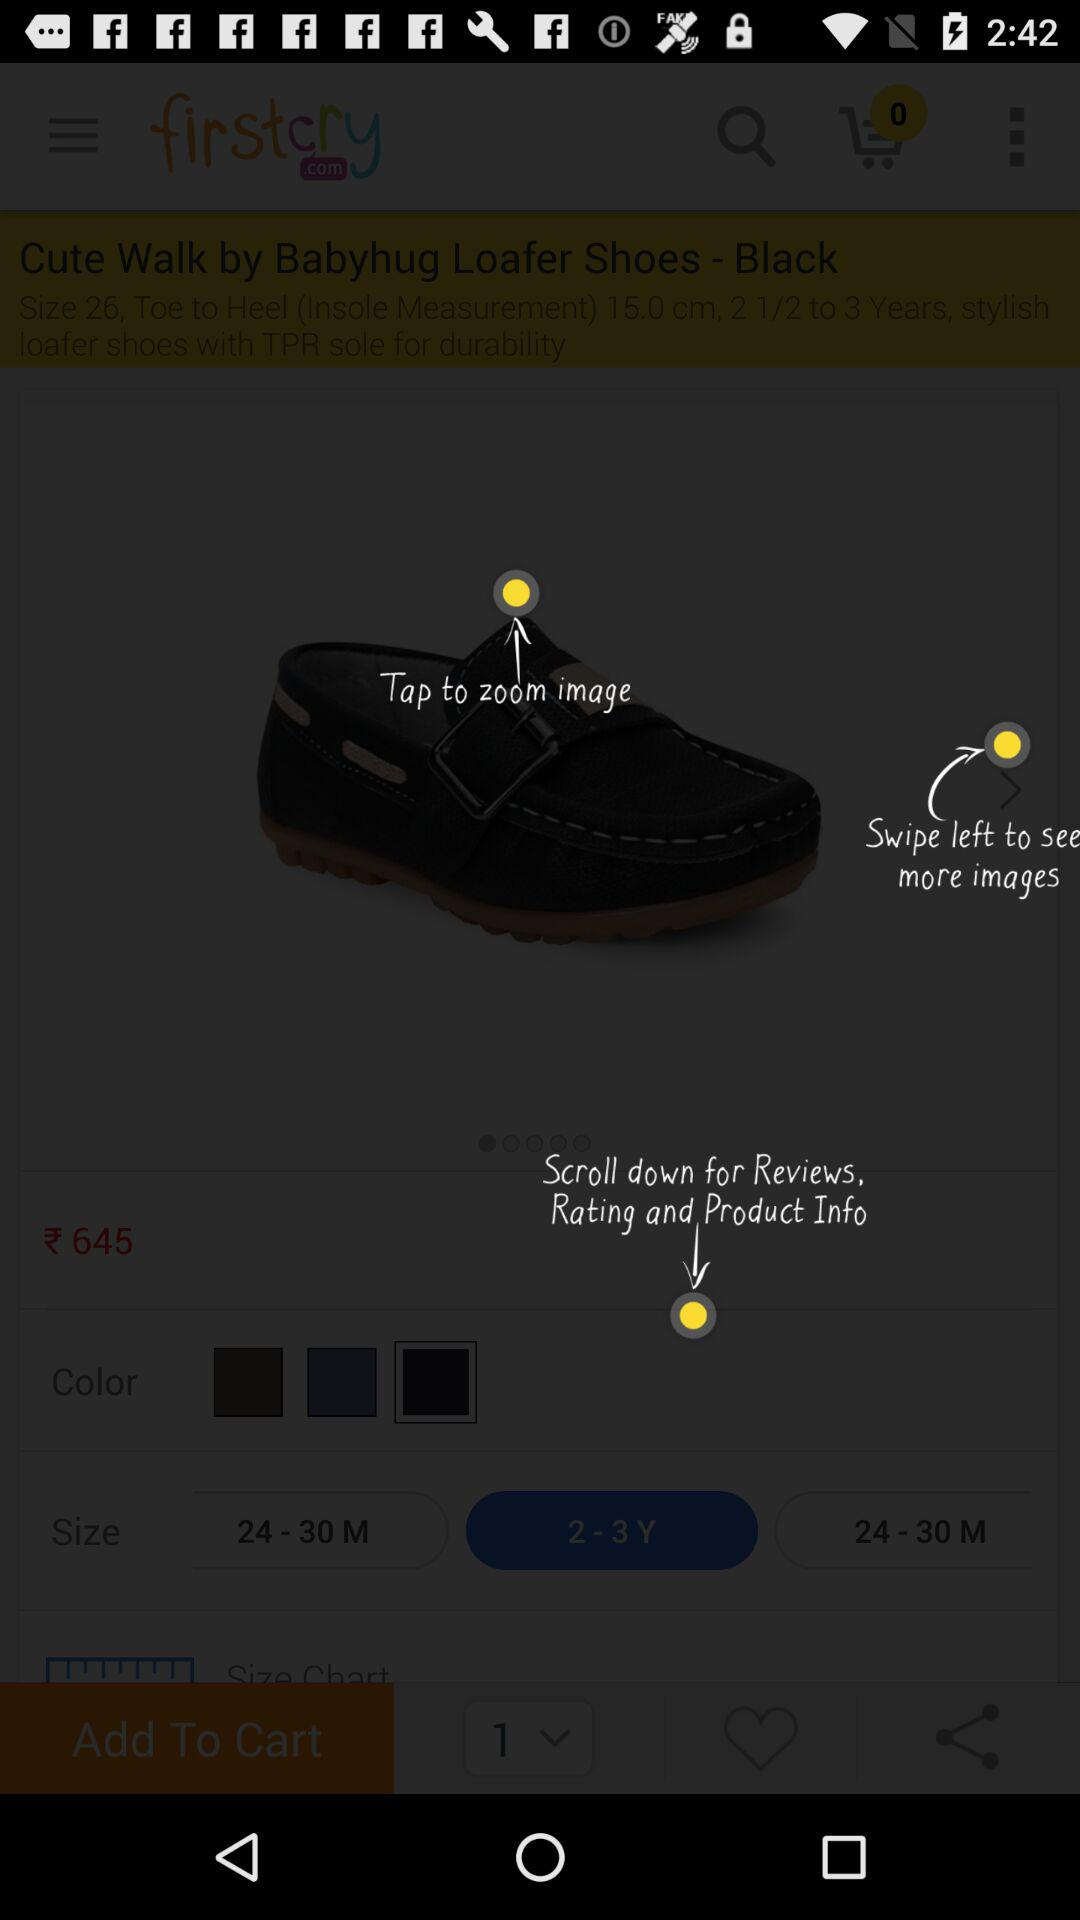How many sizes are available for this product?
Answer the question using a single word or phrase. 3 